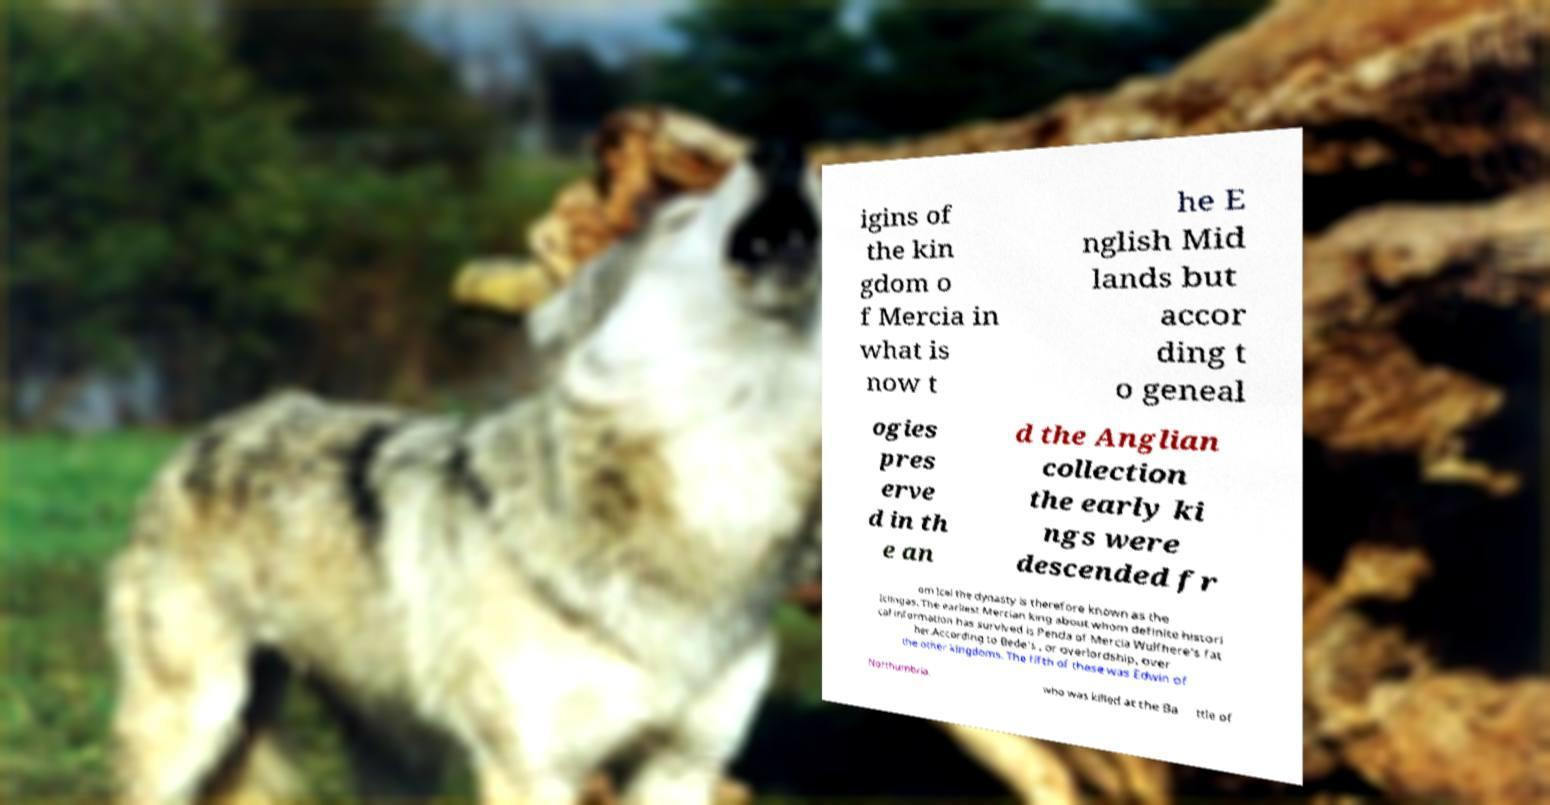Can you accurately transcribe the text from the provided image for me? igins of the kin gdom o f Mercia in what is now t he E nglish Mid lands but accor ding t o geneal ogies pres erve d in th e an d the Anglian collection the early ki ngs were descended fr om Icel the dynasty is therefore known as the Iclingas. The earliest Mercian king about whom definite histori cal information has survived is Penda of Mercia Wulfhere's fat her.According to Bede's , or overlordship, over the other kingdoms. The fifth of these was Edwin of Northumbria, who was killed at the Ba ttle of 